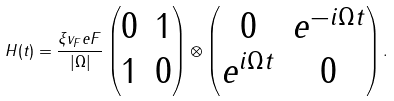Convert formula to latex. <formula><loc_0><loc_0><loc_500><loc_500>H ( t ) = \frac { \xi v _ { F } e F } { | \Omega | } \begin{pmatrix} 0 & 1 \\ 1 & 0 \end{pmatrix} \otimes \begin{pmatrix} 0 & e ^ { - i \Omega t } \\ e ^ { i \Omega t } & 0 \end{pmatrix} .</formula> 